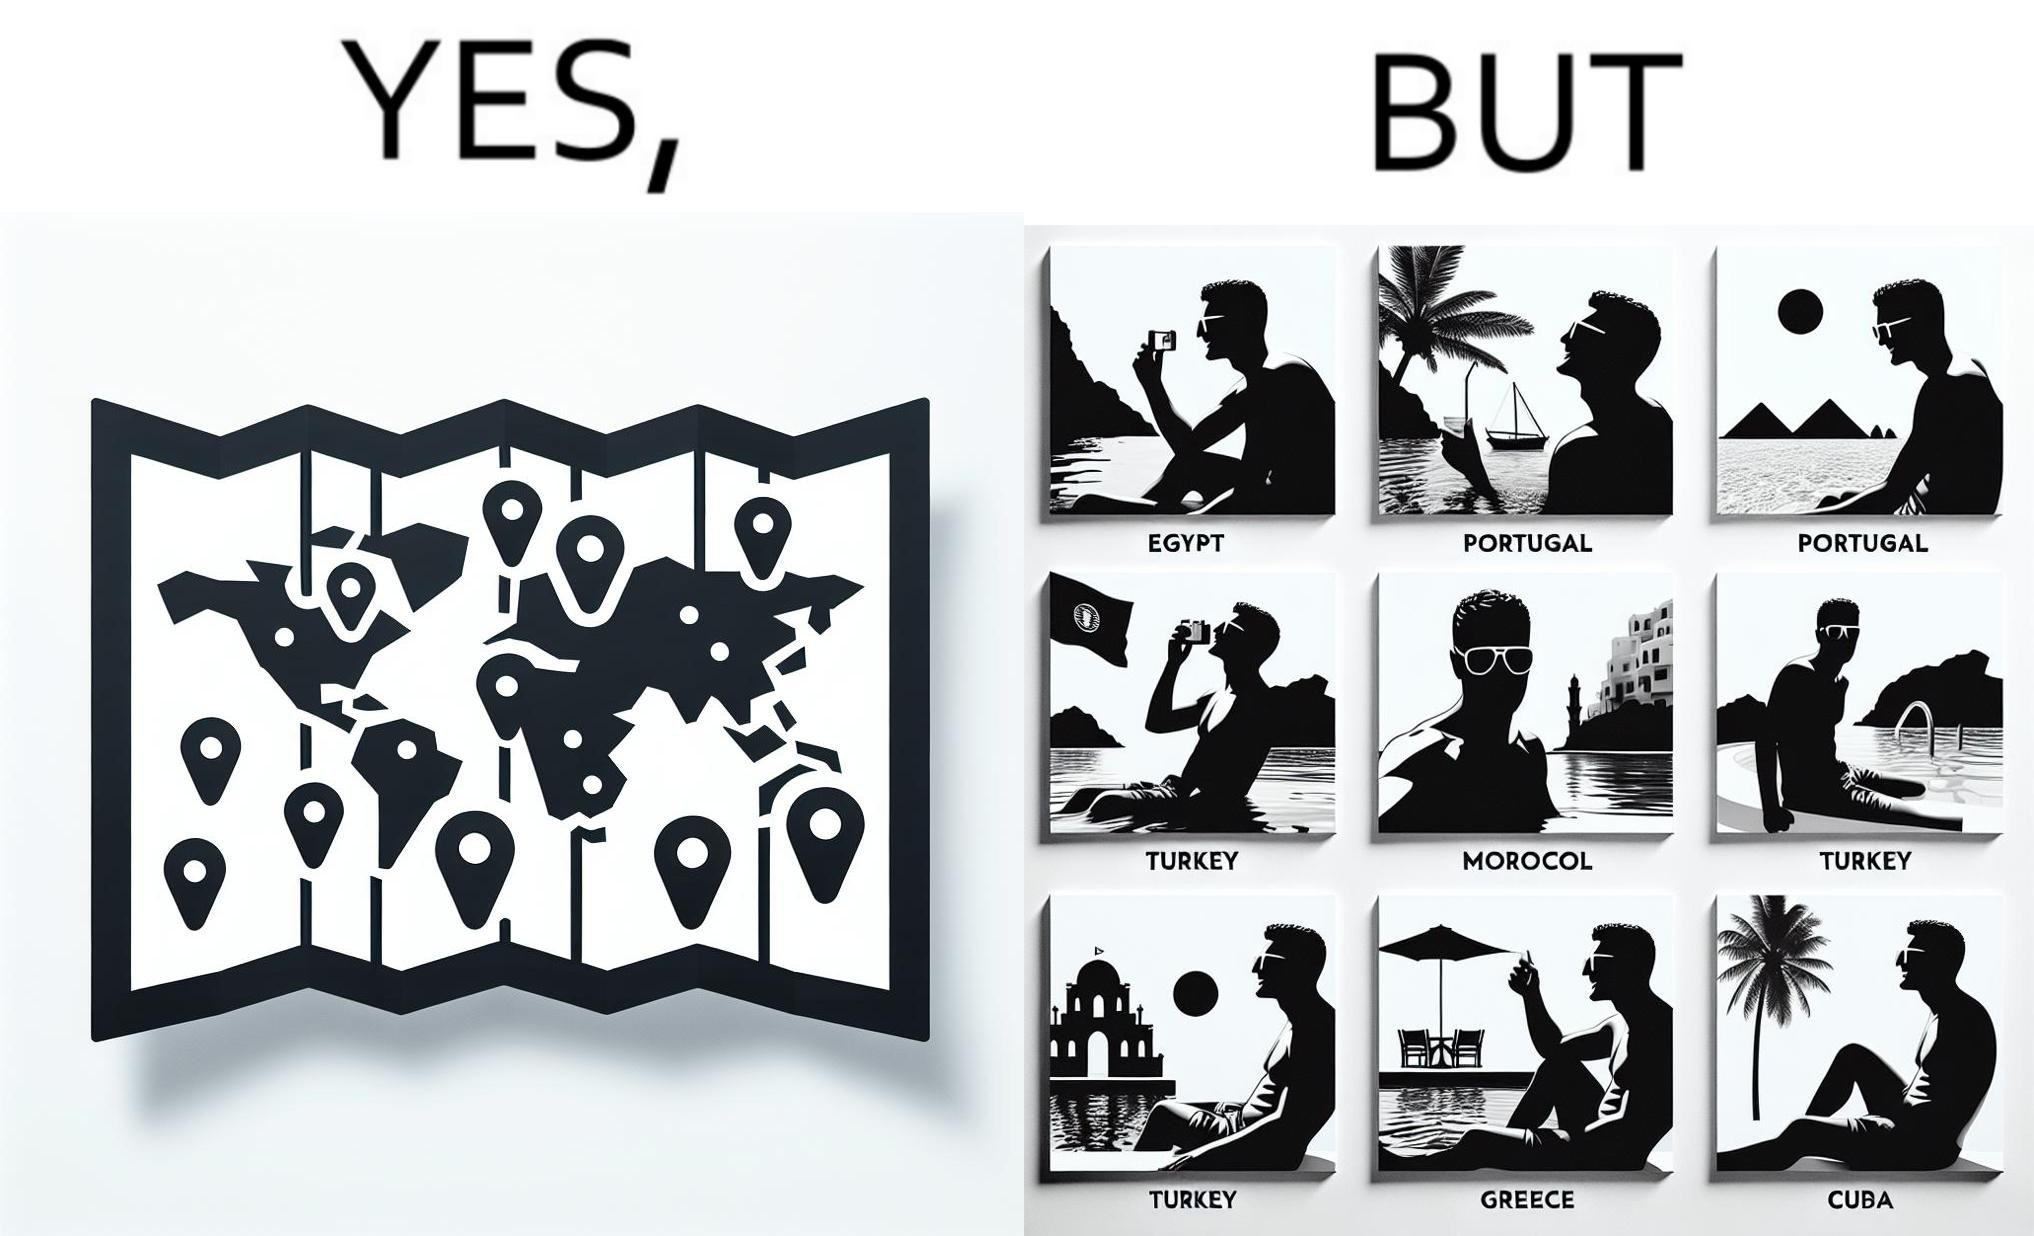Describe what you see in the left and right parts of this image. In the left part of the image: The image shows a map with pins set on places which have been visited by a person. In the right part of the image: The image shows several photos of a man wearing sunglasses  inside a pool in various countries like Egypt, Portugal, Morocco, Turkey, Greece and Cuba. 